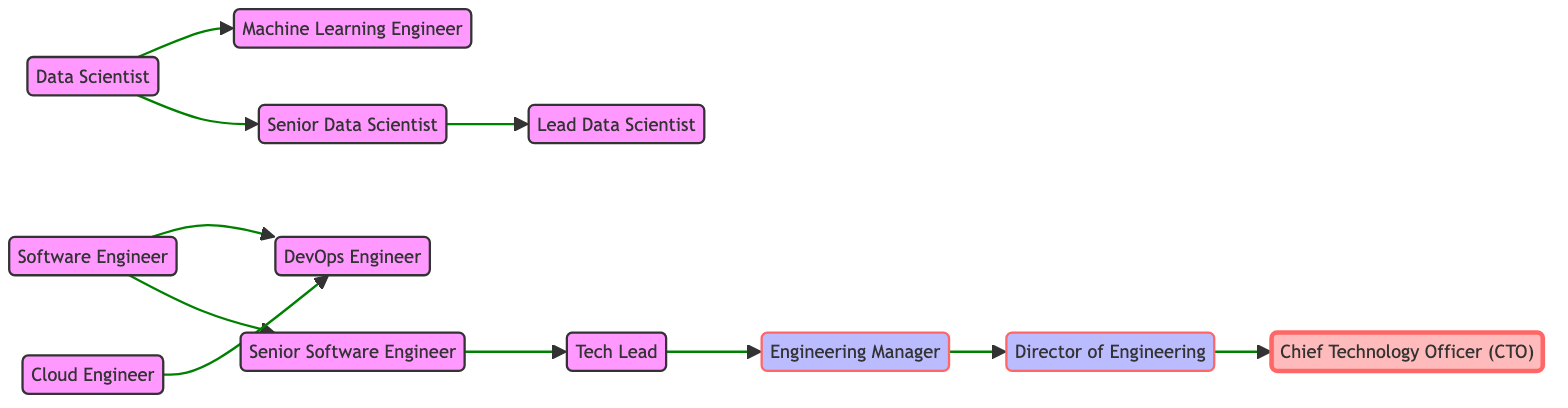What's the starting position in the software engineering path? The starting position in the software engineering career path is "Software Engineer," as it is the first node in the directed graph.
Answer: Software Engineer How many total positions are there in the technology career paths shown? By counting the nodes in the diagram, there are a total of 12 distinct positions represented.
Answer: 12 What is the last position in the software engineering career path? The last position is "Chief Technology Officer (CTO)," which is connected as the final progression from "Director of Engineering."
Answer: Chief Technology Officer (CTO) Which role leads to the Engineering Manager position? The role that leads to the Engineering Manager position is "Tech Lead," as it has a directed connection to it in the path.
Answer: Tech Lead What are the two roles that stem from the Data Scientist position? From "Data Scientist," the two roles that extend are "Senior Data Scientist" and "Machine Learning Engineer," indicating dual paths branching from that position.
Answer: Senior Data Scientist and Machine Learning Engineer How many edges connect to the Director of Engineering? There is one edge that connects to the Director of Engineering, which directly comes from the Engineering Manager position.
Answer: 1 Which position leads to both DevOps Engineer and Machine Learning Engineer? The "Software Engineer" position leads to both positions, with directed edges pointing to each.
Answer: Software Engineer What is the immediate next position after Senior Data Scientist? The immediate next position after Senior Data Scientist is "Lead Data Scientist," as indicated by the directed connection from the former to the latter.
Answer: Lead Data Scientist 